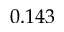Convert formula to latex. <formula><loc_0><loc_0><loc_500><loc_500>0 . 1 4 3</formula> 